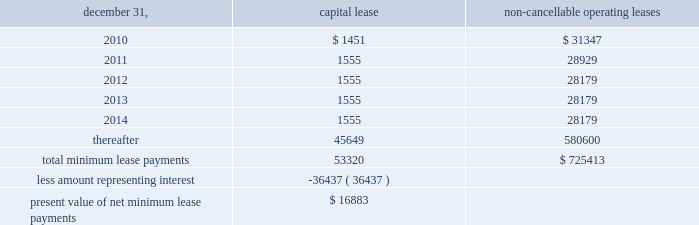Notes to consolidated financial statements of annual compensation was made .
For the years ended december 31 , 2009 , 2008 and , 2007 , we made matching contributions of approxi- mately $ 450000 , $ 503000 and $ 457000 , respectively .
Note 17 / commitments and contingencies we and our operating partnership are not presently involved in any mate- rial litigation nor , to our knowledge , is any material litigation threatened against us or our properties , other than routine litigation arising in the ordinary course of business .
Management believes the costs , if any , incurred by us and our operating partnership related to this litigation will not materially affect our financial position , operating results or liquidity .
We have entered into employment agreements with certain executives , which expire between june 2010 and january 2013 .
The minimum cash-based compensation , including base salary and guaran- teed bonus payments , associated with these employment agreements totals approximately $ 7.8 million for 2010 .
In march 1998 , we acquired an operating sub-leasehold posi- tion at 420 lexington avenue .
The operating sub-leasehold position required annual ground lease payments totaling $ 6.0 million and sub- leasehold position payments totaling $ 1.1 million ( excluding an operating sub-lease position purchased january 1999 ) .
In june 2007 , we renewed and extended the maturity date of the ground lease at 420 lexington avenue through december 31 , 2029 , with an option for further exten- sion through 2080 .
Ground lease rent payments through 2029 will total approximately $ 10.9 million per year .
Thereafter , the ground lease will be subject to a revaluation by the parties thereto .
In june 2009 , we acquired an operating sub-leasehold posi- tion at 420 lexington avenue for approximately $ 7.7 million .
These sub-leasehold positions were scheduled to mature in december 2029 .
In october 2009 , we acquired the remaining sub-leasehold position for $ 7.6 million .
The property located at 711 third avenue operates under an operating sub-lease , which expires in 2083 .
Under the sub-lease , we are responsible for ground rent payments of $ 1.55 million annually through july 2011 on the 50% ( 50 % ) portion of the fee we do not own .
The ground rent is reset after july 2011 based on the estimated fair market value of the property .
We have an option to buy out the sub-lease at a fixed future date .
The property located at 461 fifth avenue operates under a ground lease ( approximately $ 2.1 million annually ) with a term expiration date of 2027 and with two options to renew for an additional 21 years each , followed by a third option for 15 years .
We also have an option to purchase the ground lease for a fixed price on a specific date .
The property located at 625 madison avenue operates under a ground lease ( approximately $ 4.6 million annually ) with a term expiration date of 2022 and with two options to renew for an additional 23 years .
The property located at 1185 avenue of the americas oper- ates under a ground lease ( approximately $ 8.5 million in 2010 and $ 6.9 million annually thereafter ) with a term expiration of 2020 and with an option to renew for an additional 23 years .
In april 1988 , the sl green predecessor entered into a lease agreement for the property at 673 first avenue , which has been capitalized for financial statement purposes .
Land was estimated to be approximately 70% ( 70 % ) of the fair market value of the property .
The portion of the lease attributed to land is classified as an operating lease and the remainder as a capital lease .
The initial lease term is 49 years with an option for an additional 26 years .
Beginning in lease years 11 and 25 , the lessor is entitled to additional rent as defined by the lease agreement .
We continue to lease the 673 first avenue property , which has been classified as a capital lease with a cost basis of $ 12.2 million and cumulative amortization of $ 5.5 million and $ 5.2 million at december 31 , 2009 and 2008 , respectively .
The following is a schedule of future minimum lease payments under capital leases and noncancellable operating leases with initial terms in excess of one year as of december 31 , 2009 ( in thousands ) : non-cancellable december 31 , capital lease operating leases .
Note 18 / financial instruments : derivatives and hedging we recognize all derivatives on the balance sheet at fair value .
Derivatives that are not hedges must be adjusted to fair value through income .
If a derivative is a hedge , depending on the nature of the hedge , changes in the fair value of the derivative will either be offset against the change in fair value of the hedged asset , liability , or firm commitment through earn- ings , or recognized in other comprehensive income until the hedged item is recognized in earnings .
The ineffective portion of a derivative 2019s change in fair value will be immediately recognized in earnings .
Reported net income and stockholders 2019 equity may increase or decrease prospectively , depending on future levels of interest rates and other variables affecting the fair values of derivative instruments and hedged items , but will have no effect on cash flows. .
Assuming all options are exercised on 625 madison avenue , what year will the current agreement expire? 
Computations: ((2022 + 23) + 23)
Answer: 2068.0. Notes to consolidated financial statements of annual compensation was made .
For the years ended december 31 , 2009 , 2008 and , 2007 , we made matching contributions of approxi- mately $ 450000 , $ 503000 and $ 457000 , respectively .
Note 17 / commitments and contingencies we and our operating partnership are not presently involved in any mate- rial litigation nor , to our knowledge , is any material litigation threatened against us or our properties , other than routine litigation arising in the ordinary course of business .
Management believes the costs , if any , incurred by us and our operating partnership related to this litigation will not materially affect our financial position , operating results or liquidity .
We have entered into employment agreements with certain executives , which expire between june 2010 and january 2013 .
The minimum cash-based compensation , including base salary and guaran- teed bonus payments , associated with these employment agreements totals approximately $ 7.8 million for 2010 .
In march 1998 , we acquired an operating sub-leasehold posi- tion at 420 lexington avenue .
The operating sub-leasehold position required annual ground lease payments totaling $ 6.0 million and sub- leasehold position payments totaling $ 1.1 million ( excluding an operating sub-lease position purchased january 1999 ) .
In june 2007 , we renewed and extended the maturity date of the ground lease at 420 lexington avenue through december 31 , 2029 , with an option for further exten- sion through 2080 .
Ground lease rent payments through 2029 will total approximately $ 10.9 million per year .
Thereafter , the ground lease will be subject to a revaluation by the parties thereto .
In june 2009 , we acquired an operating sub-leasehold posi- tion at 420 lexington avenue for approximately $ 7.7 million .
These sub-leasehold positions were scheduled to mature in december 2029 .
In october 2009 , we acquired the remaining sub-leasehold position for $ 7.6 million .
The property located at 711 third avenue operates under an operating sub-lease , which expires in 2083 .
Under the sub-lease , we are responsible for ground rent payments of $ 1.55 million annually through july 2011 on the 50% ( 50 % ) portion of the fee we do not own .
The ground rent is reset after july 2011 based on the estimated fair market value of the property .
We have an option to buy out the sub-lease at a fixed future date .
The property located at 461 fifth avenue operates under a ground lease ( approximately $ 2.1 million annually ) with a term expiration date of 2027 and with two options to renew for an additional 21 years each , followed by a third option for 15 years .
We also have an option to purchase the ground lease for a fixed price on a specific date .
The property located at 625 madison avenue operates under a ground lease ( approximately $ 4.6 million annually ) with a term expiration date of 2022 and with two options to renew for an additional 23 years .
The property located at 1185 avenue of the americas oper- ates under a ground lease ( approximately $ 8.5 million in 2010 and $ 6.9 million annually thereafter ) with a term expiration of 2020 and with an option to renew for an additional 23 years .
In april 1988 , the sl green predecessor entered into a lease agreement for the property at 673 first avenue , which has been capitalized for financial statement purposes .
Land was estimated to be approximately 70% ( 70 % ) of the fair market value of the property .
The portion of the lease attributed to land is classified as an operating lease and the remainder as a capital lease .
The initial lease term is 49 years with an option for an additional 26 years .
Beginning in lease years 11 and 25 , the lessor is entitled to additional rent as defined by the lease agreement .
We continue to lease the 673 first avenue property , which has been classified as a capital lease with a cost basis of $ 12.2 million and cumulative amortization of $ 5.5 million and $ 5.2 million at december 31 , 2009 and 2008 , respectively .
The following is a schedule of future minimum lease payments under capital leases and noncancellable operating leases with initial terms in excess of one year as of december 31 , 2009 ( in thousands ) : non-cancellable december 31 , capital lease operating leases .
Note 18 / financial instruments : derivatives and hedging we recognize all derivatives on the balance sheet at fair value .
Derivatives that are not hedges must be adjusted to fair value through income .
If a derivative is a hedge , depending on the nature of the hedge , changes in the fair value of the derivative will either be offset against the change in fair value of the hedged asset , liability , or firm commitment through earn- ings , or recognized in other comprehensive income until the hedged item is recognized in earnings .
The ineffective portion of a derivative 2019s change in fair value will be immediately recognized in earnings .
Reported net income and stockholders 2019 equity may increase or decrease prospectively , depending on future levels of interest rates and other variables affecting the fair values of derivative instruments and hedged items , but will have no effect on cash flows. .
What percent of total minimum lease payments are due after 5 years? 
Computations: (45649 / 53320)
Answer: 0.85613. 